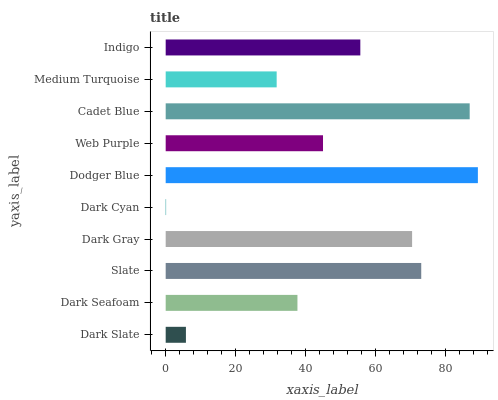Is Dark Cyan the minimum?
Answer yes or no. Yes. Is Dodger Blue the maximum?
Answer yes or no. Yes. Is Dark Seafoam the minimum?
Answer yes or no. No. Is Dark Seafoam the maximum?
Answer yes or no. No. Is Dark Seafoam greater than Dark Slate?
Answer yes or no. Yes. Is Dark Slate less than Dark Seafoam?
Answer yes or no. Yes. Is Dark Slate greater than Dark Seafoam?
Answer yes or no. No. Is Dark Seafoam less than Dark Slate?
Answer yes or no. No. Is Indigo the high median?
Answer yes or no. Yes. Is Web Purple the low median?
Answer yes or no. Yes. Is Cadet Blue the high median?
Answer yes or no. No. Is Dark Gray the low median?
Answer yes or no. No. 